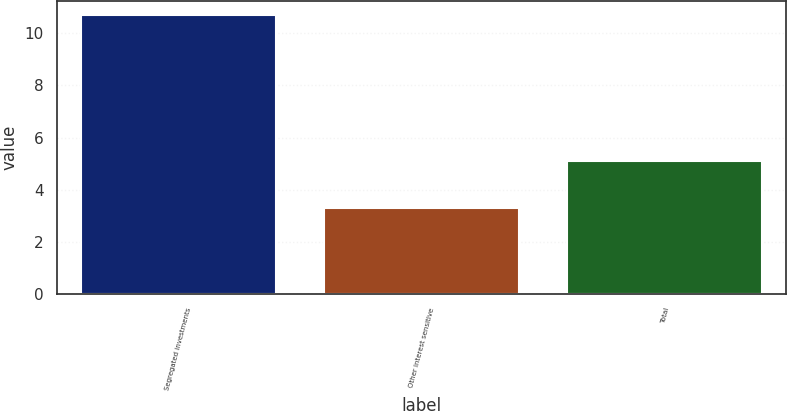<chart> <loc_0><loc_0><loc_500><loc_500><bar_chart><fcel>Segregated investments<fcel>Other interest sensitive<fcel>Total<nl><fcel>10.7<fcel>3.3<fcel>5.1<nl></chart> 